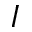<formula> <loc_0><loc_0><loc_500><loc_500>I</formula> 